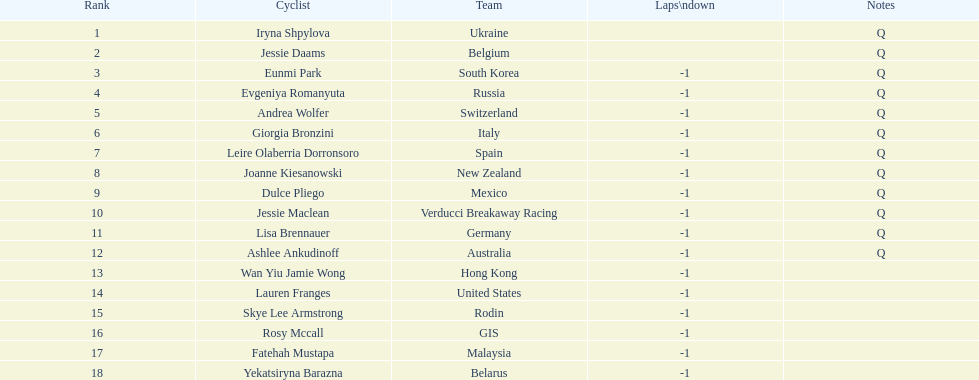Who was the top ranked competitor in this race? Iryna Shpylova. 